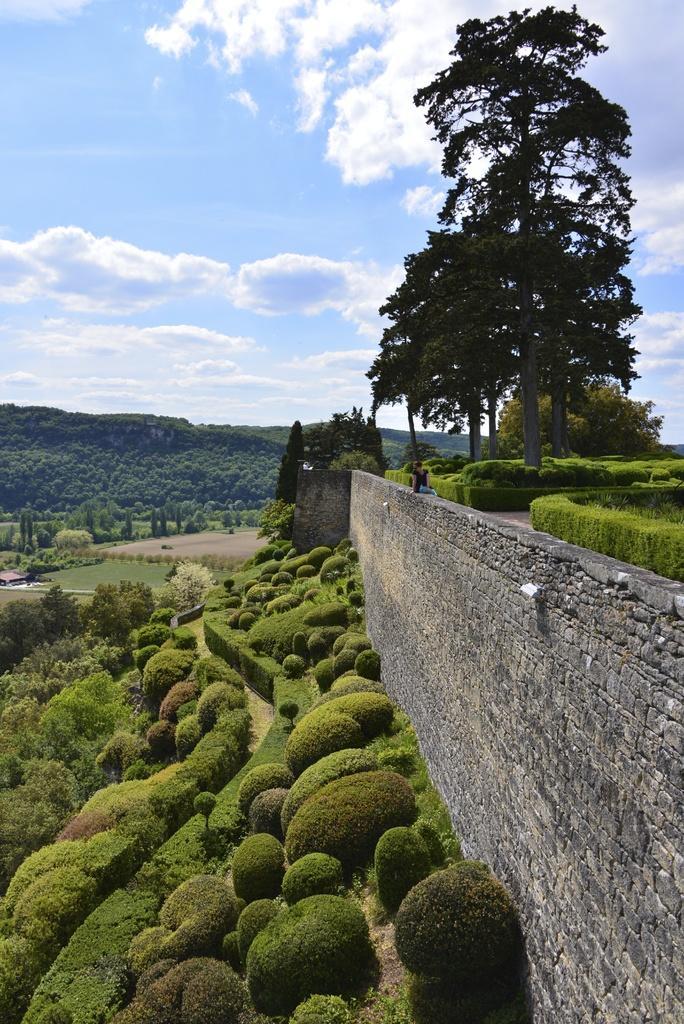How would you summarize this image in a sentence or two? On the right side of the image there is a wall. In the center of the image we can see the sky, clouds, trees, plants, grass, one house and two persons. 